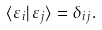Convert formula to latex. <formula><loc_0><loc_0><loc_500><loc_500>\langle \varepsilon _ { i } | \varepsilon _ { j } \rangle = \delta _ { i j } .</formula> 